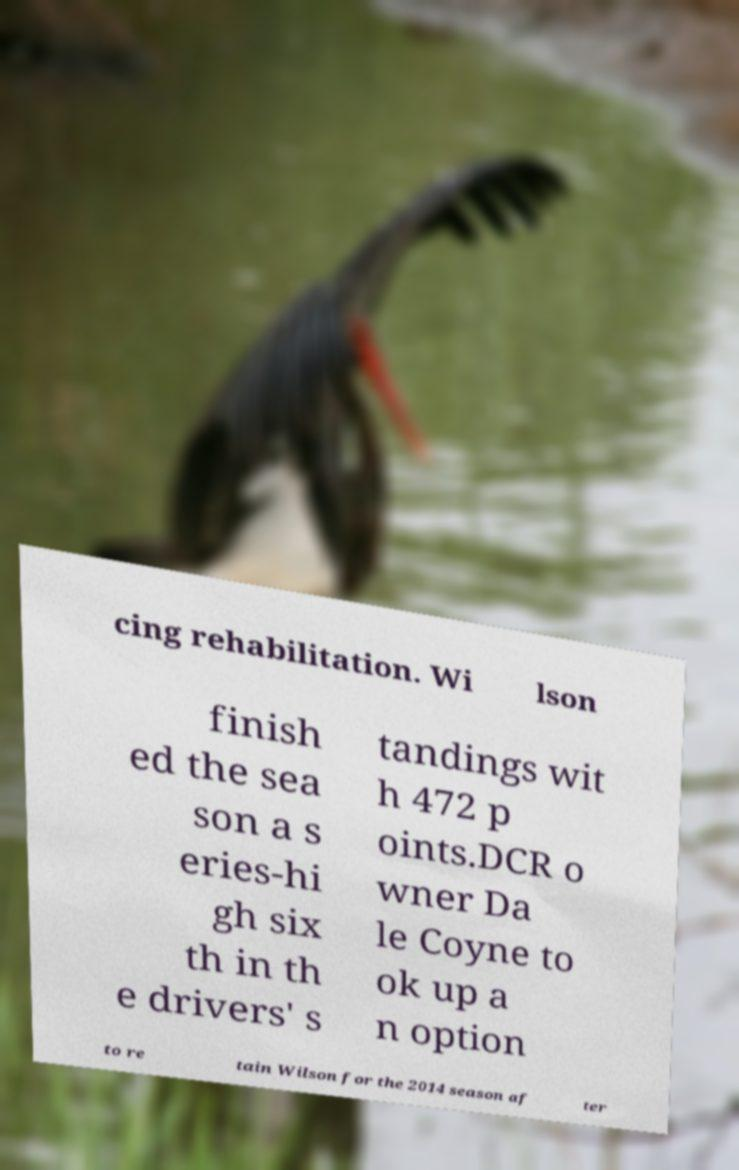Please read and relay the text visible in this image. What does it say? cing rehabilitation. Wi lson finish ed the sea son a s eries-hi gh six th in th e drivers' s tandings wit h 472 p oints.DCR o wner Da le Coyne to ok up a n option to re tain Wilson for the 2014 season af ter 